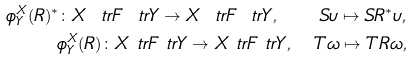Convert formula to latex. <formula><loc_0><loc_0><loc_500><loc_500>\phi ^ { X } _ { Y } ( R ) ^ { * } \colon X \ t r F \ t r Y \to X \ t r F \ t r Y , \quad S \upsilon \mapsto S R ^ { * } \upsilon , \\ \phi ^ { X } _ { Y } ( R ) \colon X \ t r F \ t r Y \to X \ t r F \ t r Y , \quad T \omega \mapsto T R \omega ,</formula> 